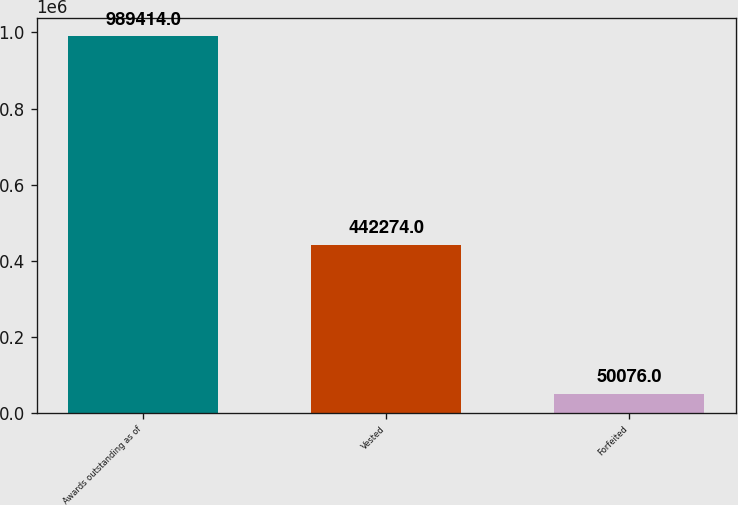Convert chart. <chart><loc_0><loc_0><loc_500><loc_500><bar_chart><fcel>Awards outstanding as of<fcel>Vested<fcel>Forfeited<nl><fcel>989414<fcel>442274<fcel>50076<nl></chart> 